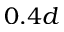Convert formula to latex. <formula><loc_0><loc_0><loc_500><loc_500>0 . 4 d</formula> 